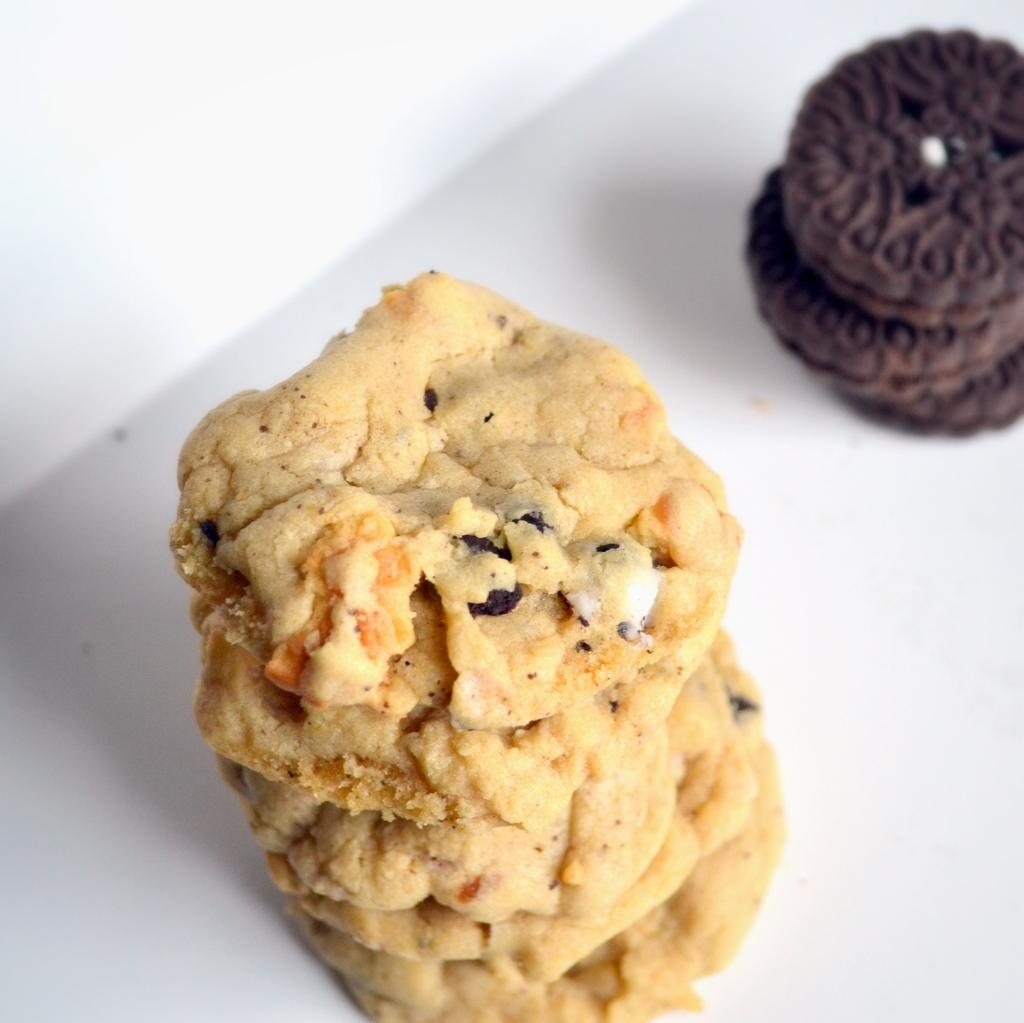What types of food items can be seen in the image? The food items in the image are in cream and brown colors. What is the color of the surface on which the food items are placed? The food items are on a white surface. How many trees are exchanging thoughts in the image? There are no trees or thoughts being exchanged in the image; it features food items on a white surface. 